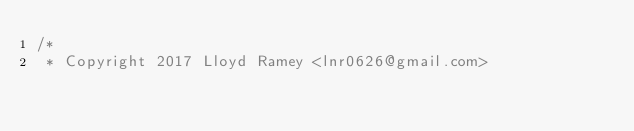<code> <loc_0><loc_0><loc_500><loc_500><_Kotlin_>/*
 * Copyright 2017 Lloyd Ramey <lnr0626@gmail.com></code> 